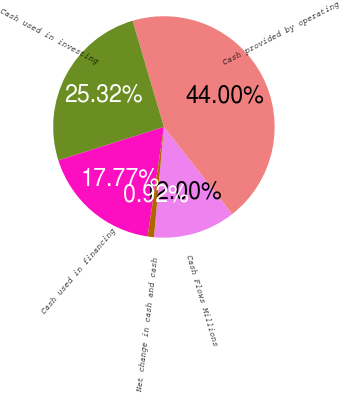<chart> <loc_0><loc_0><loc_500><loc_500><pie_chart><fcel>Cash Flows Millions<fcel>Cash provided by operating<fcel>Cash used in investing<fcel>Cash used in financing<fcel>Net change in cash and cash<nl><fcel>12.0%<fcel>44.0%<fcel>25.32%<fcel>17.77%<fcel>0.92%<nl></chart> 